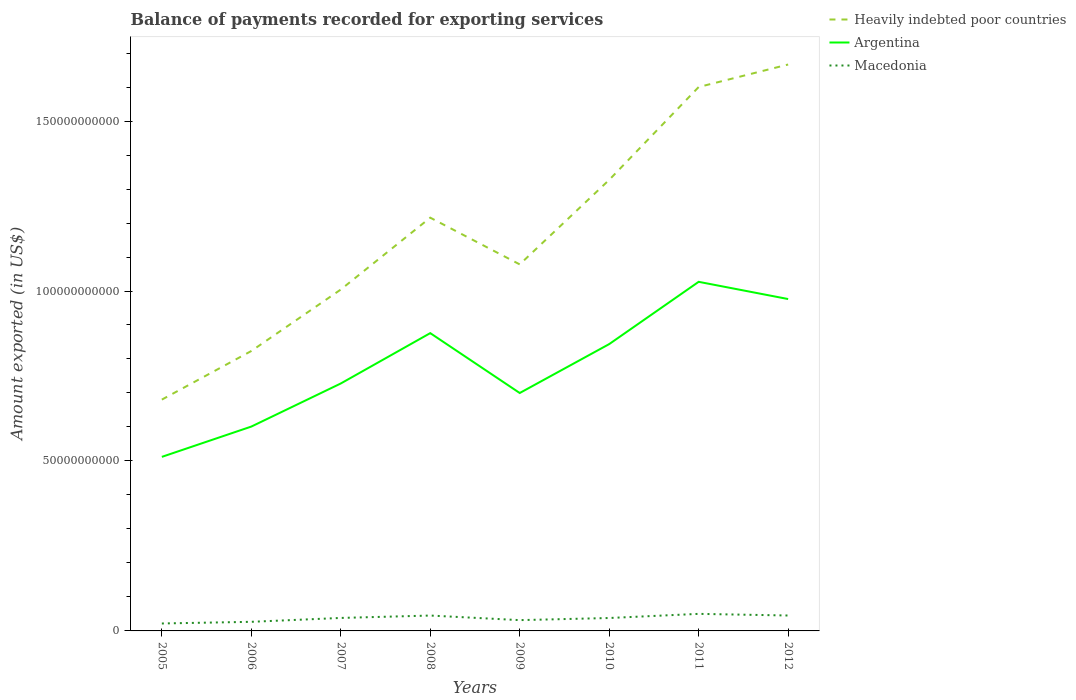How many different coloured lines are there?
Make the answer very short. 3. Across all years, what is the maximum amount exported in Macedonia?
Your answer should be compact. 2.19e+09. What is the total amount exported in Argentina in the graph?
Provide a succinct answer. -2.75e+1. What is the difference between the highest and the second highest amount exported in Macedonia?
Your response must be concise. 2.83e+09. What is the difference between the highest and the lowest amount exported in Heavily indebted poor countries?
Your response must be concise. 4. Is the amount exported in Macedonia strictly greater than the amount exported in Argentina over the years?
Offer a very short reply. Yes. How many lines are there?
Your answer should be compact. 3. How many years are there in the graph?
Offer a very short reply. 8. Does the graph contain grids?
Provide a succinct answer. No. What is the title of the graph?
Offer a terse response. Balance of payments recorded for exporting services. What is the label or title of the Y-axis?
Your response must be concise. Amount exported (in US$). What is the Amount exported (in US$) of Heavily indebted poor countries in 2005?
Offer a terse response. 6.80e+1. What is the Amount exported (in US$) of Argentina in 2005?
Provide a succinct answer. 5.12e+1. What is the Amount exported (in US$) of Macedonia in 2005?
Provide a succinct answer. 2.19e+09. What is the Amount exported (in US$) of Heavily indebted poor countries in 2006?
Make the answer very short. 8.24e+1. What is the Amount exported (in US$) of Argentina in 2006?
Your response must be concise. 6.01e+1. What is the Amount exported (in US$) in Macedonia in 2006?
Ensure brevity in your answer.  2.68e+09. What is the Amount exported (in US$) of Heavily indebted poor countries in 2007?
Offer a very short reply. 1.00e+11. What is the Amount exported (in US$) in Argentina in 2007?
Offer a terse response. 7.28e+1. What is the Amount exported (in US$) in Macedonia in 2007?
Your answer should be very brief. 3.82e+09. What is the Amount exported (in US$) of Heavily indebted poor countries in 2008?
Offer a terse response. 1.22e+11. What is the Amount exported (in US$) in Argentina in 2008?
Offer a terse response. 8.76e+1. What is the Amount exported (in US$) in Macedonia in 2008?
Your answer should be compact. 4.52e+09. What is the Amount exported (in US$) of Heavily indebted poor countries in 2009?
Your response must be concise. 1.08e+11. What is the Amount exported (in US$) in Argentina in 2009?
Offer a terse response. 7.00e+1. What is the Amount exported (in US$) in Macedonia in 2009?
Offer a terse response. 3.18e+09. What is the Amount exported (in US$) of Heavily indebted poor countries in 2010?
Offer a very short reply. 1.33e+11. What is the Amount exported (in US$) of Argentina in 2010?
Provide a short and direct response. 8.44e+1. What is the Amount exported (in US$) of Macedonia in 2010?
Give a very brief answer. 3.80e+09. What is the Amount exported (in US$) in Heavily indebted poor countries in 2011?
Your answer should be very brief. 1.60e+11. What is the Amount exported (in US$) of Argentina in 2011?
Ensure brevity in your answer.  1.03e+11. What is the Amount exported (in US$) in Macedonia in 2011?
Provide a succinct answer. 5.02e+09. What is the Amount exported (in US$) in Heavily indebted poor countries in 2012?
Offer a terse response. 1.67e+11. What is the Amount exported (in US$) in Argentina in 2012?
Ensure brevity in your answer.  9.76e+1. What is the Amount exported (in US$) in Macedonia in 2012?
Offer a terse response. 4.53e+09. Across all years, what is the maximum Amount exported (in US$) of Heavily indebted poor countries?
Keep it short and to the point. 1.67e+11. Across all years, what is the maximum Amount exported (in US$) of Argentina?
Give a very brief answer. 1.03e+11. Across all years, what is the maximum Amount exported (in US$) in Macedonia?
Keep it short and to the point. 5.02e+09. Across all years, what is the minimum Amount exported (in US$) of Heavily indebted poor countries?
Provide a short and direct response. 6.80e+1. Across all years, what is the minimum Amount exported (in US$) of Argentina?
Ensure brevity in your answer.  5.12e+1. Across all years, what is the minimum Amount exported (in US$) of Macedonia?
Your response must be concise. 2.19e+09. What is the total Amount exported (in US$) in Heavily indebted poor countries in the graph?
Give a very brief answer. 9.40e+11. What is the total Amount exported (in US$) in Argentina in the graph?
Provide a succinct answer. 6.26e+11. What is the total Amount exported (in US$) in Macedonia in the graph?
Offer a terse response. 2.97e+1. What is the difference between the Amount exported (in US$) in Heavily indebted poor countries in 2005 and that in 2006?
Your answer should be very brief. -1.43e+1. What is the difference between the Amount exported (in US$) in Argentina in 2005 and that in 2006?
Offer a very short reply. -8.91e+09. What is the difference between the Amount exported (in US$) in Macedonia in 2005 and that in 2006?
Provide a succinct answer. -4.89e+08. What is the difference between the Amount exported (in US$) of Heavily indebted poor countries in 2005 and that in 2007?
Make the answer very short. -3.24e+1. What is the difference between the Amount exported (in US$) in Argentina in 2005 and that in 2007?
Give a very brief answer. -2.16e+1. What is the difference between the Amount exported (in US$) in Macedonia in 2005 and that in 2007?
Your answer should be compact. -1.63e+09. What is the difference between the Amount exported (in US$) in Heavily indebted poor countries in 2005 and that in 2008?
Your response must be concise. -5.35e+1. What is the difference between the Amount exported (in US$) of Argentina in 2005 and that in 2008?
Your answer should be compact. -3.64e+1. What is the difference between the Amount exported (in US$) in Macedonia in 2005 and that in 2008?
Ensure brevity in your answer.  -2.33e+09. What is the difference between the Amount exported (in US$) in Heavily indebted poor countries in 2005 and that in 2009?
Your answer should be compact. -3.98e+1. What is the difference between the Amount exported (in US$) in Argentina in 2005 and that in 2009?
Keep it short and to the point. -1.88e+1. What is the difference between the Amount exported (in US$) of Macedonia in 2005 and that in 2009?
Keep it short and to the point. -9.85e+08. What is the difference between the Amount exported (in US$) of Heavily indebted poor countries in 2005 and that in 2010?
Offer a terse response. -6.46e+1. What is the difference between the Amount exported (in US$) of Argentina in 2005 and that in 2010?
Your answer should be compact. -3.32e+1. What is the difference between the Amount exported (in US$) in Macedonia in 2005 and that in 2010?
Your response must be concise. -1.61e+09. What is the difference between the Amount exported (in US$) of Heavily indebted poor countries in 2005 and that in 2011?
Keep it short and to the point. -9.20e+1. What is the difference between the Amount exported (in US$) of Argentina in 2005 and that in 2011?
Offer a terse response. -5.15e+1. What is the difference between the Amount exported (in US$) in Macedonia in 2005 and that in 2011?
Keep it short and to the point. -2.83e+09. What is the difference between the Amount exported (in US$) of Heavily indebted poor countries in 2005 and that in 2012?
Provide a succinct answer. -9.86e+1. What is the difference between the Amount exported (in US$) of Argentina in 2005 and that in 2012?
Your answer should be compact. -4.64e+1. What is the difference between the Amount exported (in US$) of Macedonia in 2005 and that in 2012?
Provide a short and direct response. -2.34e+09. What is the difference between the Amount exported (in US$) of Heavily indebted poor countries in 2006 and that in 2007?
Make the answer very short. -1.81e+1. What is the difference between the Amount exported (in US$) of Argentina in 2006 and that in 2007?
Provide a short and direct response. -1.27e+1. What is the difference between the Amount exported (in US$) in Macedonia in 2006 and that in 2007?
Offer a terse response. -1.14e+09. What is the difference between the Amount exported (in US$) of Heavily indebted poor countries in 2006 and that in 2008?
Provide a short and direct response. -3.92e+1. What is the difference between the Amount exported (in US$) of Argentina in 2006 and that in 2008?
Keep it short and to the point. -2.75e+1. What is the difference between the Amount exported (in US$) of Macedonia in 2006 and that in 2008?
Your answer should be very brief. -1.85e+09. What is the difference between the Amount exported (in US$) of Heavily indebted poor countries in 2006 and that in 2009?
Keep it short and to the point. -2.55e+1. What is the difference between the Amount exported (in US$) in Argentina in 2006 and that in 2009?
Offer a terse response. -9.87e+09. What is the difference between the Amount exported (in US$) in Macedonia in 2006 and that in 2009?
Offer a terse response. -4.97e+08. What is the difference between the Amount exported (in US$) in Heavily indebted poor countries in 2006 and that in 2010?
Make the answer very short. -5.03e+1. What is the difference between the Amount exported (in US$) of Argentina in 2006 and that in 2010?
Give a very brief answer. -2.43e+1. What is the difference between the Amount exported (in US$) in Macedonia in 2006 and that in 2010?
Provide a short and direct response. -1.12e+09. What is the difference between the Amount exported (in US$) of Heavily indebted poor countries in 2006 and that in 2011?
Offer a very short reply. -7.77e+1. What is the difference between the Amount exported (in US$) of Argentina in 2006 and that in 2011?
Offer a very short reply. -4.26e+1. What is the difference between the Amount exported (in US$) in Macedonia in 2006 and that in 2011?
Offer a terse response. -2.34e+09. What is the difference between the Amount exported (in US$) in Heavily indebted poor countries in 2006 and that in 2012?
Your answer should be compact. -8.43e+1. What is the difference between the Amount exported (in US$) of Argentina in 2006 and that in 2012?
Ensure brevity in your answer.  -3.75e+1. What is the difference between the Amount exported (in US$) in Macedonia in 2006 and that in 2012?
Offer a very short reply. -1.86e+09. What is the difference between the Amount exported (in US$) of Heavily indebted poor countries in 2007 and that in 2008?
Your response must be concise. -2.11e+1. What is the difference between the Amount exported (in US$) in Argentina in 2007 and that in 2008?
Keep it short and to the point. -1.48e+1. What is the difference between the Amount exported (in US$) in Macedonia in 2007 and that in 2008?
Ensure brevity in your answer.  -7.03e+08. What is the difference between the Amount exported (in US$) in Heavily indebted poor countries in 2007 and that in 2009?
Make the answer very short. -7.40e+09. What is the difference between the Amount exported (in US$) in Argentina in 2007 and that in 2009?
Provide a short and direct response. 2.80e+09. What is the difference between the Amount exported (in US$) in Macedonia in 2007 and that in 2009?
Make the answer very short. 6.46e+08. What is the difference between the Amount exported (in US$) of Heavily indebted poor countries in 2007 and that in 2010?
Your response must be concise. -3.23e+1. What is the difference between the Amount exported (in US$) in Argentina in 2007 and that in 2010?
Offer a very short reply. -1.16e+1. What is the difference between the Amount exported (in US$) in Macedonia in 2007 and that in 2010?
Give a very brief answer. 2.02e+07. What is the difference between the Amount exported (in US$) of Heavily indebted poor countries in 2007 and that in 2011?
Ensure brevity in your answer.  -5.96e+1. What is the difference between the Amount exported (in US$) in Argentina in 2007 and that in 2011?
Your answer should be compact. -2.99e+1. What is the difference between the Amount exported (in US$) of Macedonia in 2007 and that in 2011?
Your response must be concise. -1.20e+09. What is the difference between the Amount exported (in US$) in Heavily indebted poor countries in 2007 and that in 2012?
Your answer should be very brief. -6.62e+1. What is the difference between the Amount exported (in US$) of Argentina in 2007 and that in 2012?
Make the answer very short. -2.48e+1. What is the difference between the Amount exported (in US$) in Macedonia in 2007 and that in 2012?
Offer a very short reply. -7.14e+08. What is the difference between the Amount exported (in US$) in Heavily indebted poor countries in 2008 and that in 2009?
Your answer should be very brief. 1.37e+1. What is the difference between the Amount exported (in US$) in Argentina in 2008 and that in 2009?
Give a very brief answer. 1.76e+1. What is the difference between the Amount exported (in US$) in Macedonia in 2008 and that in 2009?
Your answer should be compact. 1.35e+09. What is the difference between the Amount exported (in US$) of Heavily indebted poor countries in 2008 and that in 2010?
Offer a very short reply. -1.11e+1. What is the difference between the Amount exported (in US$) of Argentina in 2008 and that in 2010?
Offer a terse response. 3.23e+09. What is the difference between the Amount exported (in US$) in Macedonia in 2008 and that in 2010?
Ensure brevity in your answer.  7.23e+08. What is the difference between the Amount exported (in US$) of Heavily indebted poor countries in 2008 and that in 2011?
Your answer should be compact. -3.84e+1. What is the difference between the Amount exported (in US$) of Argentina in 2008 and that in 2011?
Your answer should be compact. -1.51e+1. What is the difference between the Amount exported (in US$) of Macedonia in 2008 and that in 2011?
Provide a short and direct response. -4.95e+08. What is the difference between the Amount exported (in US$) in Heavily indebted poor countries in 2008 and that in 2012?
Offer a terse response. -4.51e+1. What is the difference between the Amount exported (in US$) in Argentina in 2008 and that in 2012?
Offer a very short reply. -1.00e+1. What is the difference between the Amount exported (in US$) in Macedonia in 2008 and that in 2012?
Keep it short and to the point. -1.05e+07. What is the difference between the Amount exported (in US$) of Heavily indebted poor countries in 2009 and that in 2010?
Provide a short and direct response. -2.49e+1. What is the difference between the Amount exported (in US$) of Argentina in 2009 and that in 2010?
Ensure brevity in your answer.  -1.44e+1. What is the difference between the Amount exported (in US$) of Macedonia in 2009 and that in 2010?
Offer a very short reply. -6.26e+08. What is the difference between the Amount exported (in US$) in Heavily indebted poor countries in 2009 and that in 2011?
Make the answer very short. -5.22e+1. What is the difference between the Amount exported (in US$) of Argentina in 2009 and that in 2011?
Give a very brief answer. -3.27e+1. What is the difference between the Amount exported (in US$) in Macedonia in 2009 and that in 2011?
Make the answer very short. -1.84e+09. What is the difference between the Amount exported (in US$) of Heavily indebted poor countries in 2009 and that in 2012?
Provide a short and direct response. -5.88e+1. What is the difference between the Amount exported (in US$) in Argentina in 2009 and that in 2012?
Give a very brief answer. -2.76e+1. What is the difference between the Amount exported (in US$) of Macedonia in 2009 and that in 2012?
Provide a short and direct response. -1.36e+09. What is the difference between the Amount exported (in US$) in Heavily indebted poor countries in 2010 and that in 2011?
Offer a very short reply. -2.73e+1. What is the difference between the Amount exported (in US$) of Argentina in 2010 and that in 2011?
Make the answer very short. -1.83e+1. What is the difference between the Amount exported (in US$) in Macedonia in 2010 and that in 2011?
Provide a succinct answer. -1.22e+09. What is the difference between the Amount exported (in US$) in Heavily indebted poor countries in 2010 and that in 2012?
Your response must be concise. -3.39e+1. What is the difference between the Amount exported (in US$) of Argentina in 2010 and that in 2012?
Your answer should be compact. -1.33e+1. What is the difference between the Amount exported (in US$) of Macedonia in 2010 and that in 2012?
Provide a succinct answer. -7.34e+08. What is the difference between the Amount exported (in US$) of Heavily indebted poor countries in 2011 and that in 2012?
Offer a very short reply. -6.62e+09. What is the difference between the Amount exported (in US$) of Argentina in 2011 and that in 2012?
Your answer should be very brief. 5.07e+09. What is the difference between the Amount exported (in US$) of Macedonia in 2011 and that in 2012?
Offer a very short reply. 4.85e+08. What is the difference between the Amount exported (in US$) of Heavily indebted poor countries in 2005 and the Amount exported (in US$) of Argentina in 2006?
Your response must be concise. 7.93e+09. What is the difference between the Amount exported (in US$) in Heavily indebted poor countries in 2005 and the Amount exported (in US$) in Macedonia in 2006?
Offer a very short reply. 6.54e+1. What is the difference between the Amount exported (in US$) in Argentina in 2005 and the Amount exported (in US$) in Macedonia in 2006?
Offer a terse response. 4.85e+1. What is the difference between the Amount exported (in US$) of Heavily indebted poor countries in 2005 and the Amount exported (in US$) of Argentina in 2007?
Your response must be concise. -4.74e+09. What is the difference between the Amount exported (in US$) in Heavily indebted poor countries in 2005 and the Amount exported (in US$) in Macedonia in 2007?
Offer a very short reply. 6.42e+1. What is the difference between the Amount exported (in US$) of Argentina in 2005 and the Amount exported (in US$) of Macedonia in 2007?
Keep it short and to the point. 4.74e+1. What is the difference between the Amount exported (in US$) of Heavily indebted poor countries in 2005 and the Amount exported (in US$) of Argentina in 2008?
Ensure brevity in your answer.  -1.96e+1. What is the difference between the Amount exported (in US$) of Heavily indebted poor countries in 2005 and the Amount exported (in US$) of Macedonia in 2008?
Make the answer very short. 6.35e+1. What is the difference between the Amount exported (in US$) of Argentina in 2005 and the Amount exported (in US$) of Macedonia in 2008?
Keep it short and to the point. 4.67e+1. What is the difference between the Amount exported (in US$) in Heavily indebted poor countries in 2005 and the Amount exported (in US$) in Argentina in 2009?
Provide a succinct answer. -1.94e+09. What is the difference between the Amount exported (in US$) in Heavily indebted poor countries in 2005 and the Amount exported (in US$) in Macedonia in 2009?
Give a very brief answer. 6.49e+1. What is the difference between the Amount exported (in US$) of Argentina in 2005 and the Amount exported (in US$) of Macedonia in 2009?
Ensure brevity in your answer.  4.80e+1. What is the difference between the Amount exported (in US$) in Heavily indebted poor countries in 2005 and the Amount exported (in US$) in Argentina in 2010?
Your response must be concise. -1.63e+1. What is the difference between the Amount exported (in US$) in Heavily indebted poor countries in 2005 and the Amount exported (in US$) in Macedonia in 2010?
Ensure brevity in your answer.  6.42e+1. What is the difference between the Amount exported (in US$) in Argentina in 2005 and the Amount exported (in US$) in Macedonia in 2010?
Offer a very short reply. 4.74e+1. What is the difference between the Amount exported (in US$) of Heavily indebted poor countries in 2005 and the Amount exported (in US$) of Argentina in 2011?
Your answer should be very brief. -3.47e+1. What is the difference between the Amount exported (in US$) in Heavily indebted poor countries in 2005 and the Amount exported (in US$) in Macedonia in 2011?
Give a very brief answer. 6.30e+1. What is the difference between the Amount exported (in US$) in Argentina in 2005 and the Amount exported (in US$) in Macedonia in 2011?
Offer a terse response. 4.62e+1. What is the difference between the Amount exported (in US$) in Heavily indebted poor countries in 2005 and the Amount exported (in US$) in Argentina in 2012?
Provide a short and direct response. -2.96e+1. What is the difference between the Amount exported (in US$) in Heavily indebted poor countries in 2005 and the Amount exported (in US$) in Macedonia in 2012?
Provide a succinct answer. 6.35e+1. What is the difference between the Amount exported (in US$) of Argentina in 2005 and the Amount exported (in US$) of Macedonia in 2012?
Provide a short and direct response. 4.67e+1. What is the difference between the Amount exported (in US$) in Heavily indebted poor countries in 2006 and the Amount exported (in US$) in Argentina in 2007?
Offer a very short reply. 9.56e+09. What is the difference between the Amount exported (in US$) of Heavily indebted poor countries in 2006 and the Amount exported (in US$) of Macedonia in 2007?
Offer a very short reply. 7.85e+1. What is the difference between the Amount exported (in US$) of Argentina in 2006 and the Amount exported (in US$) of Macedonia in 2007?
Offer a very short reply. 5.63e+1. What is the difference between the Amount exported (in US$) of Heavily indebted poor countries in 2006 and the Amount exported (in US$) of Argentina in 2008?
Keep it short and to the point. -5.26e+09. What is the difference between the Amount exported (in US$) in Heavily indebted poor countries in 2006 and the Amount exported (in US$) in Macedonia in 2008?
Your response must be concise. 7.78e+1. What is the difference between the Amount exported (in US$) in Argentina in 2006 and the Amount exported (in US$) in Macedonia in 2008?
Give a very brief answer. 5.56e+1. What is the difference between the Amount exported (in US$) in Heavily indebted poor countries in 2006 and the Amount exported (in US$) in Argentina in 2009?
Offer a terse response. 1.24e+1. What is the difference between the Amount exported (in US$) in Heavily indebted poor countries in 2006 and the Amount exported (in US$) in Macedonia in 2009?
Keep it short and to the point. 7.92e+1. What is the difference between the Amount exported (in US$) in Argentina in 2006 and the Amount exported (in US$) in Macedonia in 2009?
Make the answer very short. 5.69e+1. What is the difference between the Amount exported (in US$) of Heavily indebted poor countries in 2006 and the Amount exported (in US$) of Argentina in 2010?
Your response must be concise. -2.03e+09. What is the difference between the Amount exported (in US$) in Heavily indebted poor countries in 2006 and the Amount exported (in US$) in Macedonia in 2010?
Offer a very short reply. 7.85e+1. What is the difference between the Amount exported (in US$) in Argentina in 2006 and the Amount exported (in US$) in Macedonia in 2010?
Your answer should be very brief. 5.63e+1. What is the difference between the Amount exported (in US$) of Heavily indebted poor countries in 2006 and the Amount exported (in US$) of Argentina in 2011?
Your answer should be very brief. -2.04e+1. What is the difference between the Amount exported (in US$) in Heavily indebted poor countries in 2006 and the Amount exported (in US$) in Macedonia in 2011?
Your response must be concise. 7.73e+1. What is the difference between the Amount exported (in US$) of Argentina in 2006 and the Amount exported (in US$) of Macedonia in 2011?
Ensure brevity in your answer.  5.51e+1. What is the difference between the Amount exported (in US$) in Heavily indebted poor countries in 2006 and the Amount exported (in US$) in Argentina in 2012?
Offer a very short reply. -1.53e+1. What is the difference between the Amount exported (in US$) in Heavily indebted poor countries in 2006 and the Amount exported (in US$) in Macedonia in 2012?
Your response must be concise. 7.78e+1. What is the difference between the Amount exported (in US$) of Argentina in 2006 and the Amount exported (in US$) of Macedonia in 2012?
Provide a succinct answer. 5.56e+1. What is the difference between the Amount exported (in US$) in Heavily indebted poor countries in 2007 and the Amount exported (in US$) in Argentina in 2008?
Provide a succinct answer. 1.28e+1. What is the difference between the Amount exported (in US$) in Heavily indebted poor countries in 2007 and the Amount exported (in US$) in Macedonia in 2008?
Provide a short and direct response. 9.59e+1. What is the difference between the Amount exported (in US$) of Argentina in 2007 and the Amount exported (in US$) of Macedonia in 2008?
Give a very brief answer. 6.83e+1. What is the difference between the Amount exported (in US$) of Heavily indebted poor countries in 2007 and the Amount exported (in US$) of Argentina in 2009?
Your answer should be compact. 3.04e+1. What is the difference between the Amount exported (in US$) of Heavily indebted poor countries in 2007 and the Amount exported (in US$) of Macedonia in 2009?
Give a very brief answer. 9.73e+1. What is the difference between the Amount exported (in US$) of Argentina in 2007 and the Amount exported (in US$) of Macedonia in 2009?
Your answer should be compact. 6.96e+1. What is the difference between the Amount exported (in US$) in Heavily indebted poor countries in 2007 and the Amount exported (in US$) in Argentina in 2010?
Your answer should be compact. 1.61e+1. What is the difference between the Amount exported (in US$) in Heavily indebted poor countries in 2007 and the Amount exported (in US$) in Macedonia in 2010?
Offer a terse response. 9.66e+1. What is the difference between the Amount exported (in US$) in Argentina in 2007 and the Amount exported (in US$) in Macedonia in 2010?
Your answer should be compact. 6.90e+1. What is the difference between the Amount exported (in US$) in Heavily indebted poor countries in 2007 and the Amount exported (in US$) in Argentina in 2011?
Keep it short and to the point. -2.27e+09. What is the difference between the Amount exported (in US$) in Heavily indebted poor countries in 2007 and the Amount exported (in US$) in Macedonia in 2011?
Provide a succinct answer. 9.54e+1. What is the difference between the Amount exported (in US$) of Argentina in 2007 and the Amount exported (in US$) of Macedonia in 2011?
Provide a short and direct response. 6.78e+1. What is the difference between the Amount exported (in US$) in Heavily indebted poor countries in 2007 and the Amount exported (in US$) in Argentina in 2012?
Your answer should be compact. 2.80e+09. What is the difference between the Amount exported (in US$) of Heavily indebted poor countries in 2007 and the Amount exported (in US$) of Macedonia in 2012?
Make the answer very short. 9.59e+1. What is the difference between the Amount exported (in US$) of Argentina in 2007 and the Amount exported (in US$) of Macedonia in 2012?
Keep it short and to the point. 6.83e+1. What is the difference between the Amount exported (in US$) in Heavily indebted poor countries in 2008 and the Amount exported (in US$) in Argentina in 2009?
Provide a short and direct response. 5.16e+1. What is the difference between the Amount exported (in US$) in Heavily indebted poor countries in 2008 and the Amount exported (in US$) in Macedonia in 2009?
Provide a short and direct response. 1.18e+11. What is the difference between the Amount exported (in US$) of Argentina in 2008 and the Amount exported (in US$) of Macedonia in 2009?
Your response must be concise. 8.44e+1. What is the difference between the Amount exported (in US$) in Heavily indebted poor countries in 2008 and the Amount exported (in US$) in Argentina in 2010?
Your response must be concise. 3.72e+1. What is the difference between the Amount exported (in US$) in Heavily indebted poor countries in 2008 and the Amount exported (in US$) in Macedonia in 2010?
Your answer should be very brief. 1.18e+11. What is the difference between the Amount exported (in US$) in Argentina in 2008 and the Amount exported (in US$) in Macedonia in 2010?
Provide a succinct answer. 8.38e+1. What is the difference between the Amount exported (in US$) in Heavily indebted poor countries in 2008 and the Amount exported (in US$) in Argentina in 2011?
Offer a terse response. 1.89e+1. What is the difference between the Amount exported (in US$) in Heavily indebted poor countries in 2008 and the Amount exported (in US$) in Macedonia in 2011?
Keep it short and to the point. 1.17e+11. What is the difference between the Amount exported (in US$) in Argentina in 2008 and the Amount exported (in US$) in Macedonia in 2011?
Make the answer very short. 8.26e+1. What is the difference between the Amount exported (in US$) in Heavily indebted poor countries in 2008 and the Amount exported (in US$) in Argentina in 2012?
Provide a succinct answer. 2.39e+1. What is the difference between the Amount exported (in US$) in Heavily indebted poor countries in 2008 and the Amount exported (in US$) in Macedonia in 2012?
Give a very brief answer. 1.17e+11. What is the difference between the Amount exported (in US$) in Argentina in 2008 and the Amount exported (in US$) in Macedonia in 2012?
Ensure brevity in your answer.  8.31e+1. What is the difference between the Amount exported (in US$) in Heavily indebted poor countries in 2009 and the Amount exported (in US$) in Argentina in 2010?
Provide a short and direct response. 2.34e+1. What is the difference between the Amount exported (in US$) in Heavily indebted poor countries in 2009 and the Amount exported (in US$) in Macedonia in 2010?
Your answer should be very brief. 1.04e+11. What is the difference between the Amount exported (in US$) in Argentina in 2009 and the Amount exported (in US$) in Macedonia in 2010?
Your answer should be very brief. 6.62e+1. What is the difference between the Amount exported (in US$) in Heavily indebted poor countries in 2009 and the Amount exported (in US$) in Argentina in 2011?
Offer a very short reply. 5.13e+09. What is the difference between the Amount exported (in US$) of Heavily indebted poor countries in 2009 and the Amount exported (in US$) of Macedonia in 2011?
Give a very brief answer. 1.03e+11. What is the difference between the Amount exported (in US$) of Argentina in 2009 and the Amount exported (in US$) of Macedonia in 2011?
Provide a short and direct response. 6.50e+1. What is the difference between the Amount exported (in US$) of Heavily indebted poor countries in 2009 and the Amount exported (in US$) of Argentina in 2012?
Offer a terse response. 1.02e+1. What is the difference between the Amount exported (in US$) in Heavily indebted poor countries in 2009 and the Amount exported (in US$) in Macedonia in 2012?
Your response must be concise. 1.03e+11. What is the difference between the Amount exported (in US$) of Argentina in 2009 and the Amount exported (in US$) of Macedonia in 2012?
Offer a terse response. 6.55e+1. What is the difference between the Amount exported (in US$) in Heavily indebted poor countries in 2010 and the Amount exported (in US$) in Argentina in 2011?
Keep it short and to the point. 3.00e+1. What is the difference between the Amount exported (in US$) of Heavily indebted poor countries in 2010 and the Amount exported (in US$) of Macedonia in 2011?
Give a very brief answer. 1.28e+11. What is the difference between the Amount exported (in US$) in Argentina in 2010 and the Amount exported (in US$) in Macedonia in 2011?
Your answer should be compact. 7.94e+1. What is the difference between the Amount exported (in US$) of Heavily indebted poor countries in 2010 and the Amount exported (in US$) of Argentina in 2012?
Make the answer very short. 3.51e+1. What is the difference between the Amount exported (in US$) of Heavily indebted poor countries in 2010 and the Amount exported (in US$) of Macedonia in 2012?
Keep it short and to the point. 1.28e+11. What is the difference between the Amount exported (in US$) of Argentina in 2010 and the Amount exported (in US$) of Macedonia in 2012?
Offer a very short reply. 7.98e+1. What is the difference between the Amount exported (in US$) in Heavily indebted poor countries in 2011 and the Amount exported (in US$) in Argentina in 2012?
Your response must be concise. 6.24e+1. What is the difference between the Amount exported (in US$) in Heavily indebted poor countries in 2011 and the Amount exported (in US$) in Macedonia in 2012?
Ensure brevity in your answer.  1.55e+11. What is the difference between the Amount exported (in US$) in Argentina in 2011 and the Amount exported (in US$) in Macedonia in 2012?
Provide a short and direct response. 9.82e+1. What is the average Amount exported (in US$) of Heavily indebted poor countries per year?
Give a very brief answer. 1.17e+11. What is the average Amount exported (in US$) in Argentina per year?
Offer a very short reply. 7.83e+1. What is the average Amount exported (in US$) in Macedonia per year?
Give a very brief answer. 3.72e+09. In the year 2005, what is the difference between the Amount exported (in US$) in Heavily indebted poor countries and Amount exported (in US$) in Argentina?
Your answer should be compact. 1.68e+1. In the year 2005, what is the difference between the Amount exported (in US$) in Heavily indebted poor countries and Amount exported (in US$) in Macedonia?
Offer a terse response. 6.59e+1. In the year 2005, what is the difference between the Amount exported (in US$) in Argentina and Amount exported (in US$) in Macedonia?
Your response must be concise. 4.90e+1. In the year 2006, what is the difference between the Amount exported (in US$) in Heavily indebted poor countries and Amount exported (in US$) in Argentina?
Make the answer very short. 2.22e+1. In the year 2006, what is the difference between the Amount exported (in US$) of Heavily indebted poor countries and Amount exported (in US$) of Macedonia?
Ensure brevity in your answer.  7.97e+1. In the year 2006, what is the difference between the Amount exported (in US$) in Argentina and Amount exported (in US$) in Macedonia?
Provide a succinct answer. 5.74e+1. In the year 2007, what is the difference between the Amount exported (in US$) of Heavily indebted poor countries and Amount exported (in US$) of Argentina?
Make the answer very short. 2.76e+1. In the year 2007, what is the difference between the Amount exported (in US$) of Heavily indebted poor countries and Amount exported (in US$) of Macedonia?
Provide a succinct answer. 9.66e+1. In the year 2007, what is the difference between the Amount exported (in US$) in Argentina and Amount exported (in US$) in Macedonia?
Keep it short and to the point. 6.90e+1. In the year 2008, what is the difference between the Amount exported (in US$) in Heavily indebted poor countries and Amount exported (in US$) in Argentina?
Offer a terse response. 3.40e+1. In the year 2008, what is the difference between the Amount exported (in US$) in Heavily indebted poor countries and Amount exported (in US$) in Macedonia?
Make the answer very short. 1.17e+11. In the year 2008, what is the difference between the Amount exported (in US$) in Argentina and Amount exported (in US$) in Macedonia?
Give a very brief answer. 8.31e+1. In the year 2009, what is the difference between the Amount exported (in US$) of Heavily indebted poor countries and Amount exported (in US$) of Argentina?
Offer a terse response. 3.78e+1. In the year 2009, what is the difference between the Amount exported (in US$) in Heavily indebted poor countries and Amount exported (in US$) in Macedonia?
Offer a terse response. 1.05e+11. In the year 2009, what is the difference between the Amount exported (in US$) in Argentina and Amount exported (in US$) in Macedonia?
Keep it short and to the point. 6.68e+1. In the year 2010, what is the difference between the Amount exported (in US$) in Heavily indebted poor countries and Amount exported (in US$) in Argentina?
Offer a very short reply. 4.83e+1. In the year 2010, what is the difference between the Amount exported (in US$) of Heavily indebted poor countries and Amount exported (in US$) of Macedonia?
Make the answer very short. 1.29e+11. In the year 2010, what is the difference between the Amount exported (in US$) of Argentina and Amount exported (in US$) of Macedonia?
Offer a terse response. 8.06e+1. In the year 2011, what is the difference between the Amount exported (in US$) in Heavily indebted poor countries and Amount exported (in US$) in Argentina?
Offer a very short reply. 5.73e+1. In the year 2011, what is the difference between the Amount exported (in US$) of Heavily indebted poor countries and Amount exported (in US$) of Macedonia?
Provide a succinct answer. 1.55e+11. In the year 2011, what is the difference between the Amount exported (in US$) in Argentina and Amount exported (in US$) in Macedonia?
Your answer should be compact. 9.77e+1. In the year 2012, what is the difference between the Amount exported (in US$) of Heavily indebted poor countries and Amount exported (in US$) of Argentina?
Ensure brevity in your answer.  6.90e+1. In the year 2012, what is the difference between the Amount exported (in US$) in Heavily indebted poor countries and Amount exported (in US$) in Macedonia?
Provide a succinct answer. 1.62e+11. In the year 2012, what is the difference between the Amount exported (in US$) of Argentina and Amount exported (in US$) of Macedonia?
Give a very brief answer. 9.31e+1. What is the ratio of the Amount exported (in US$) of Heavily indebted poor countries in 2005 to that in 2006?
Your answer should be compact. 0.83. What is the ratio of the Amount exported (in US$) in Argentina in 2005 to that in 2006?
Your response must be concise. 0.85. What is the ratio of the Amount exported (in US$) of Macedonia in 2005 to that in 2006?
Provide a succinct answer. 0.82. What is the ratio of the Amount exported (in US$) of Heavily indebted poor countries in 2005 to that in 2007?
Make the answer very short. 0.68. What is the ratio of the Amount exported (in US$) in Argentina in 2005 to that in 2007?
Provide a succinct answer. 0.7. What is the ratio of the Amount exported (in US$) of Macedonia in 2005 to that in 2007?
Make the answer very short. 0.57. What is the ratio of the Amount exported (in US$) in Heavily indebted poor countries in 2005 to that in 2008?
Your answer should be compact. 0.56. What is the ratio of the Amount exported (in US$) in Argentina in 2005 to that in 2008?
Keep it short and to the point. 0.58. What is the ratio of the Amount exported (in US$) in Macedonia in 2005 to that in 2008?
Provide a succinct answer. 0.48. What is the ratio of the Amount exported (in US$) in Heavily indebted poor countries in 2005 to that in 2009?
Provide a succinct answer. 0.63. What is the ratio of the Amount exported (in US$) in Argentina in 2005 to that in 2009?
Provide a short and direct response. 0.73. What is the ratio of the Amount exported (in US$) of Macedonia in 2005 to that in 2009?
Provide a succinct answer. 0.69. What is the ratio of the Amount exported (in US$) of Heavily indebted poor countries in 2005 to that in 2010?
Your answer should be compact. 0.51. What is the ratio of the Amount exported (in US$) of Argentina in 2005 to that in 2010?
Provide a succinct answer. 0.61. What is the ratio of the Amount exported (in US$) in Macedonia in 2005 to that in 2010?
Make the answer very short. 0.58. What is the ratio of the Amount exported (in US$) in Heavily indebted poor countries in 2005 to that in 2011?
Offer a very short reply. 0.43. What is the ratio of the Amount exported (in US$) in Argentina in 2005 to that in 2011?
Ensure brevity in your answer.  0.5. What is the ratio of the Amount exported (in US$) of Macedonia in 2005 to that in 2011?
Offer a terse response. 0.44. What is the ratio of the Amount exported (in US$) of Heavily indebted poor countries in 2005 to that in 2012?
Provide a succinct answer. 0.41. What is the ratio of the Amount exported (in US$) in Argentina in 2005 to that in 2012?
Give a very brief answer. 0.52. What is the ratio of the Amount exported (in US$) of Macedonia in 2005 to that in 2012?
Give a very brief answer. 0.48. What is the ratio of the Amount exported (in US$) of Heavily indebted poor countries in 2006 to that in 2007?
Your response must be concise. 0.82. What is the ratio of the Amount exported (in US$) in Argentina in 2006 to that in 2007?
Provide a short and direct response. 0.83. What is the ratio of the Amount exported (in US$) in Macedonia in 2006 to that in 2007?
Offer a very short reply. 0.7. What is the ratio of the Amount exported (in US$) of Heavily indebted poor countries in 2006 to that in 2008?
Keep it short and to the point. 0.68. What is the ratio of the Amount exported (in US$) of Argentina in 2006 to that in 2008?
Offer a terse response. 0.69. What is the ratio of the Amount exported (in US$) in Macedonia in 2006 to that in 2008?
Ensure brevity in your answer.  0.59. What is the ratio of the Amount exported (in US$) of Heavily indebted poor countries in 2006 to that in 2009?
Provide a short and direct response. 0.76. What is the ratio of the Amount exported (in US$) in Argentina in 2006 to that in 2009?
Your response must be concise. 0.86. What is the ratio of the Amount exported (in US$) in Macedonia in 2006 to that in 2009?
Make the answer very short. 0.84. What is the ratio of the Amount exported (in US$) in Heavily indebted poor countries in 2006 to that in 2010?
Your answer should be compact. 0.62. What is the ratio of the Amount exported (in US$) in Argentina in 2006 to that in 2010?
Offer a very short reply. 0.71. What is the ratio of the Amount exported (in US$) of Macedonia in 2006 to that in 2010?
Provide a succinct answer. 0.7. What is the ratio of the Amount exported (in US$) of Heavily indebted poor countries in 2006 to that in 2011?
Offer a terse response. 0.51. What is the ratio of the Amount exported (in US$) in Argentina in 2006 to that in 2011?
Provide a succinct answer. 0.59. What is the ratio of the Amount exported (in US$) in Macedonia in 2006 to that in 2011?
Your answer should be compact. 0.53. What is the ratio of the Amount exported (in US$) of Heavily indebted poor countries in 2006 to that in 2012?
Keep it short and to the point. 0.49. What is the ratio of the Amount exported (in US$) in Argentina in 2006 to that in 2012?
Offer a terse response. 0.62. What is the ratio of the Amount exported (in US$) of Macedonia in 2006 to that in 2012?
Provide a short and direct response. 0.59. What is the ratio of the Amount exported (in US$) of Heavily indebted poor countries in 2007 to that in 2008?
Keep it short and to the point. 0.83. What is the ratio of the Amount exported (in US$) in Argentina in 2007 to that in 2008?
Your response must be concise. 0.83. What is the ratio of the Amount exported (in US$) in Macedonia in 2007 to that in 2008?
Provide a succinct answer. 0.84. What is the ratio of the Amount exported (in US$) in Heavily indebted poor countries in 2007 to that in 2009?
Provide a succinct answer. 0.93. What is the ratio of the Amount exported (in US$) in Macedonia in 2007 to that in 2009?
Make the answer very short. 1.2. What is the ratio of the Amount exported (in US$) of Heavily indebted poor countries in 2007 to that in 2010?
Ensure brevity in your answer.  0.76. What is the ratio of the Amount exported (in US$) in Argentina in 2007 to that in 2010?
Provide a succinct answer. 0.86. What is the ratio of the Amount exported (in US$) of Heavily indebted poor countries in 2007 to that in 2011?
Offer a very short reply. 0.63. What is the ratio of the Amount exported (in US$) in Argentina in 2007 to that in 2011?
Make the answer very short. 0.71. What is the ratio of the Amount exported (in US$) in Macedonia in 2007 to that in 2011?
Your answer should be compact. 0.76. What is the ratio of the Amount exported (in US$) of Heavily indebted poor countries in 2007 to that in 2012?
Provide a succinct answer. 0.6. What is the ratio of the Amount exported (in US$) of Argentina in 2007 to that in 2012?
Your answer should be very brief. 0.75. What is the ratio of the Amount exported (in US$) in Macedonia in 2007 to that in 2012?
Your answer should be very brief. 0.84. What is the ratio of the Amount exported (in US$) of Heavily indebted poor countries in 2008 to that in 2009?
Give a very brief answer. 1.13. What is the ratio of the Amount exported (in US$) of Argentina in 2008 to that in 2009?
Keep it short and to the point. 1.25. What is the ratio of the Amount exported (in US$) of Macedonia in 2008 to that in 2009?
Your answer should be compact. 1.42. What is the ratio of the Amount exported (in US$) of Heavily indebted poor countries in 2008 to that in 2010?
Give a very brief answer. 0.92. What is the ratio of the Amount exported (in US$) in Argentina in 2008 to that in 2010?
Your response must be concise. 1.04. What is the ratio of the Amount exported (in US$) of Macedonia in 2008 to that in 2010?
Provide a short and direct response. 1.19. What is the ratio of the Amount exported (in US$) in Heavily indebted poor countries in 2008 to that in 2011?
Offer a terse response. 0.76. What is the ratio of the Amount exported (in US$) of Argentina in 2008 to that in 2011?
Offer a terse response. 0.85. What is the ratio of the Amount exported (in US$) in Macedonia in 2008 to that in 2011?
Provide a short and direct response. 0.9. What is the ratio of the Amount exported (in US$) of Heavily indebted poor countries in 2008 to that in 2012?
Offer a terse response. 0.73. What is the ratio of the Amount exported (in US$) in Argentina in 2008 to that in 2012?
Give a very brief answer. 0.9. What is the ratio of the Amount exported (in US$) in Heavily indebted poor countries in 2009 to that in 2010?
Ensure brevity in your answer.  0.81. What is the ratio of the Amount exported (in US$) of Argentina in 2009 to that in 2010?
Make the answer very short. 0.83. What is the ratio of the Amount exported (in US$) in Macedonia in 2009 to that in 2010?
Offer a terse response. 0.84. What is the ratio of the Amount exported (in US$) of Heavily indebted poor countries in 2009 to that in 2011?
Your answer should be compact. 0.67. What is the ratio of the Amount exported (in US$) in Argentina in 2009 to that in 2011?
Your answer should be very brief. 0.68. What is the ratio of the Amount exported (in US$) of Macedonia in 2009 to that in 2011?
Offer a very short reply. 0.63. What is the ratio of the Amount exported (in US$) of Heavily indebted poor countries in 2009 to that in 2012?
Provide a short and direct response. 0.65. What is the ratio of the Amount exported (in US$) of Argentina in 2009 to that in 2012?
Make the answer very short. 0.72. What is the ratio of the Amount exported (in US$) of Macedonia in 2009 to that in 2012?
Give a very brief answer. 0.7. What is the ratio of the Amount exported (in US$) of Heavily indebted poor countries in 2010 to that in 2011?
Your response must be concise. 0.83. What is the ratio of the Amount exported (in US$) in Argentina in 2010 to that in 2011?
Ensure brevity in your answer.  0.82. What is the ratio of the Amount exported (in US$) in Macedonia in 2010 to that in 2011?
Offer a terse response. 0.76. What is the ratio of the Amount exported (in US$) in Heavily indebted poor countries in 2010 to that in 2012?
Provide a short and direct response. 0.8. What is the ratio of the Amount exported (in US$) of Argentina in 2010 to that in 2012?
Keep it short and to the point. 0.86. What is the ratio of the Amount exported (in US$) of Macedonia in 2010 to that in 2012?
Provide a succinct answer. 0.84. What is the ratio of the Amount exported (in US$) in Heavily indebted poor countries in 2011 to that in 2012?
Offer a terse response. 0.96. What is the ratio of the Amount exported (in US$) of Argentina in 2011 to that in 2012?
Give a very brief answer. 1.05. What is the ratio of the Amount exported (in US$) in Macedonia in 2011 to that in 2012?
Make the answer very short. 1.11. What is the difference between the highest and the second highest Amount exported (in US$) in Heavily indebted poor countries?
Ensure brevity in your answer.  6.62e+09. What is the difference between the highest and the second highest Amount exported (in US$) of Argentina?
Your response must be concise. 5.07e+09. What is the difference between the highest and the second highest Amount exported (in US$) of Macedonia?
Offer a terse response. 4.85e+08. What is the difference between the highest and the lowest Amount exported (in US$) in Heavily indebted poor countries?
Your response must be concise. 9.86e+1. What is the difference between the highest and the lowest Amount exported (in US$) in Argentina?
Keep it short and to the point. 5.15e+1. What is the difference between the highest and the lowest Amount exported (in US$) of Macedonia?
Offer a terse response. 2.83e+09. 